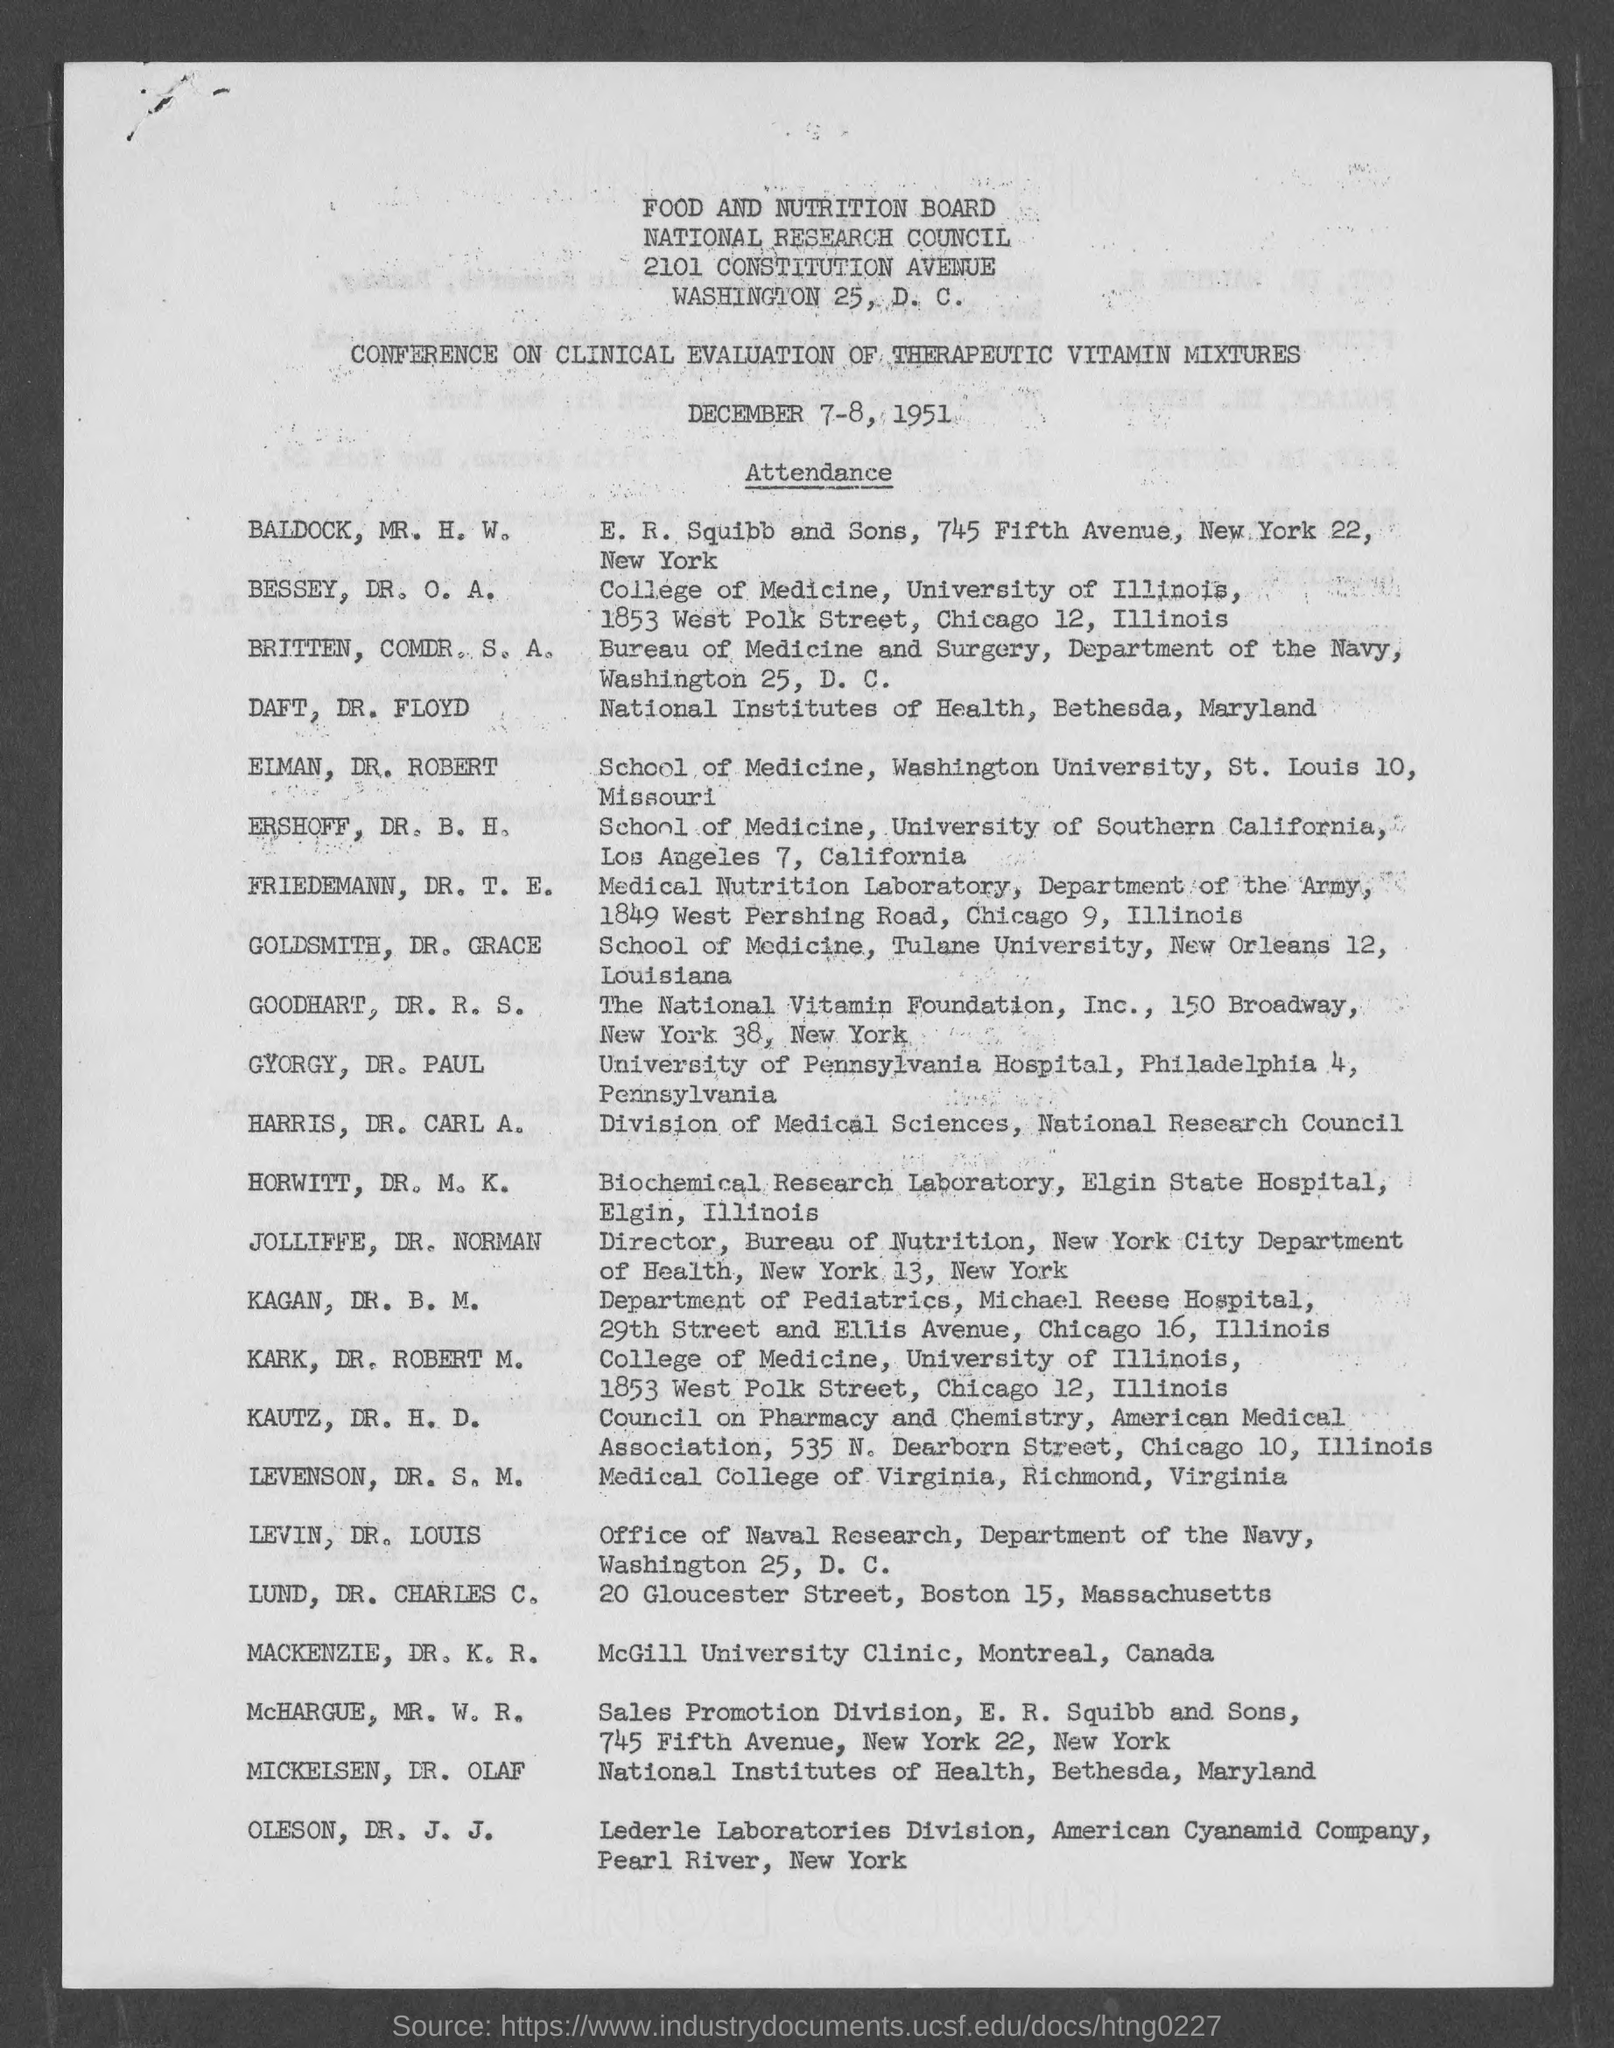List a handful of essential elements in this visual. The conference is scheduled to take place on December 7-8, 1951. The Food and Nutrition Board is mentioned. The National Research Council is the council that is mentioned. 